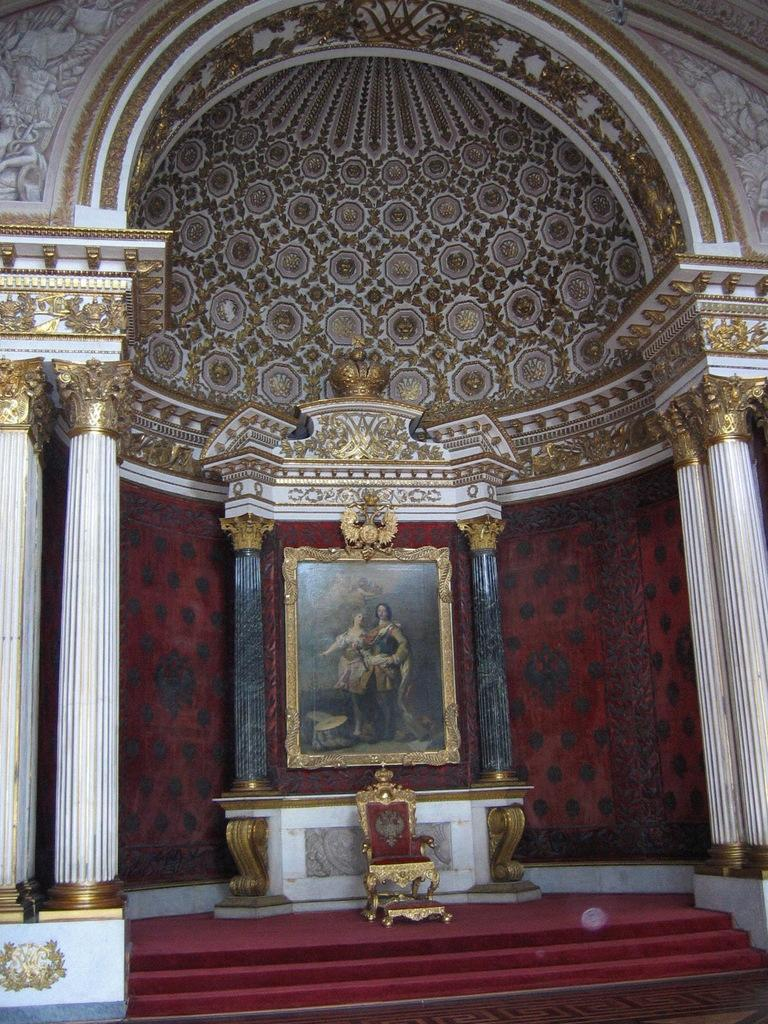Where is the chair located in the image? The chair is above the stairs in the image. What is located behind the chair? There is a photo frame behind the chair. What architectural features are present beside the chair? There are pillars beside the chair. What can be seen at the top of the image? There is a dome visible at the top of the image. Where is the shelf located in the image? There is no shelf present in the image. What type of card can be seen on the chair in the image? There are no cards present in the image. 